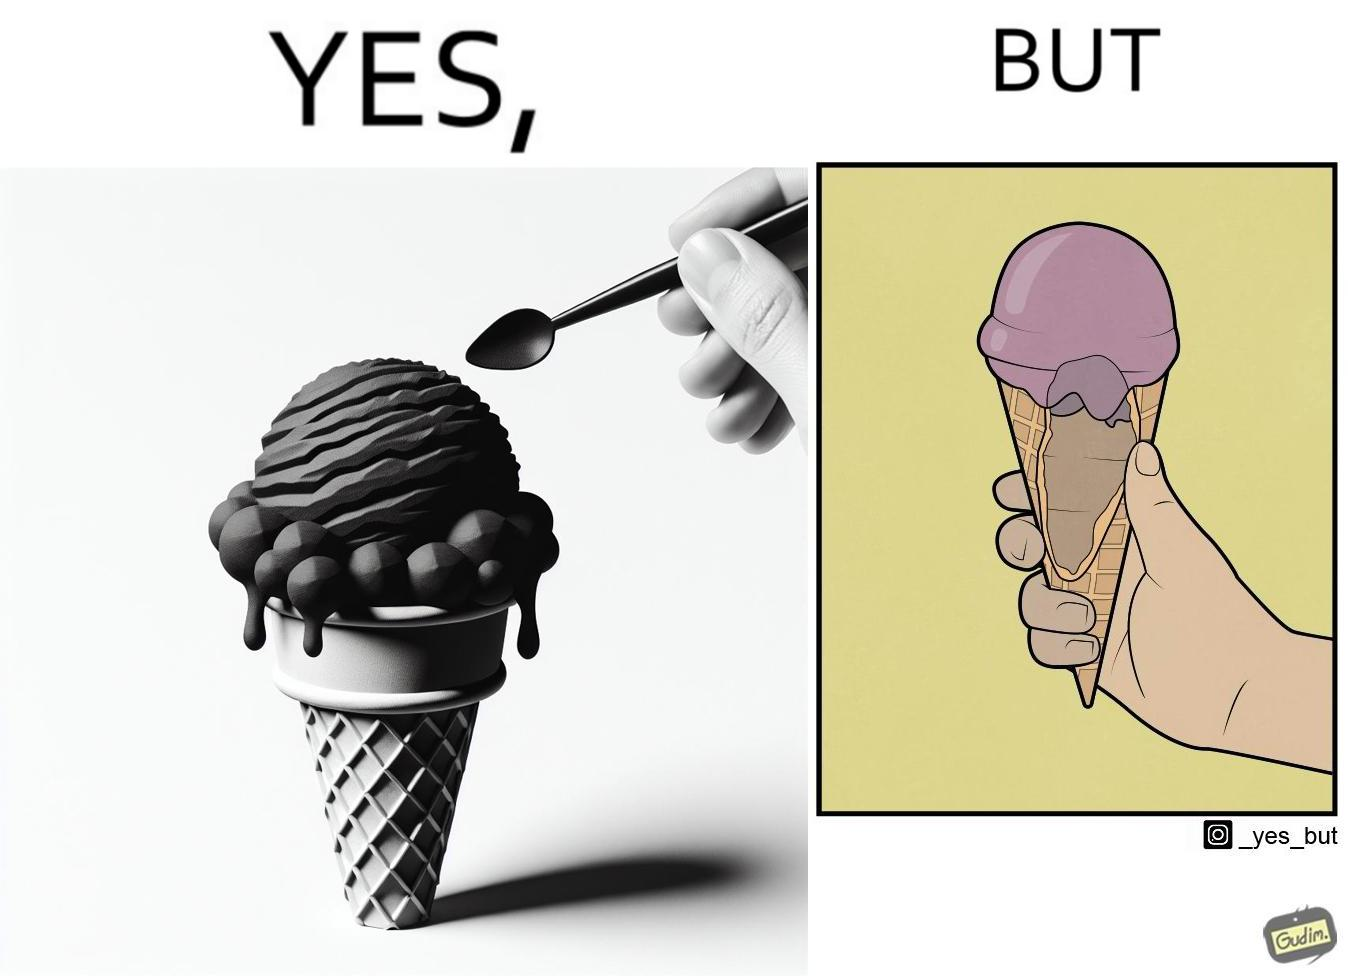Is this image satirical or non-satirical? Yes, this image is satirical. 